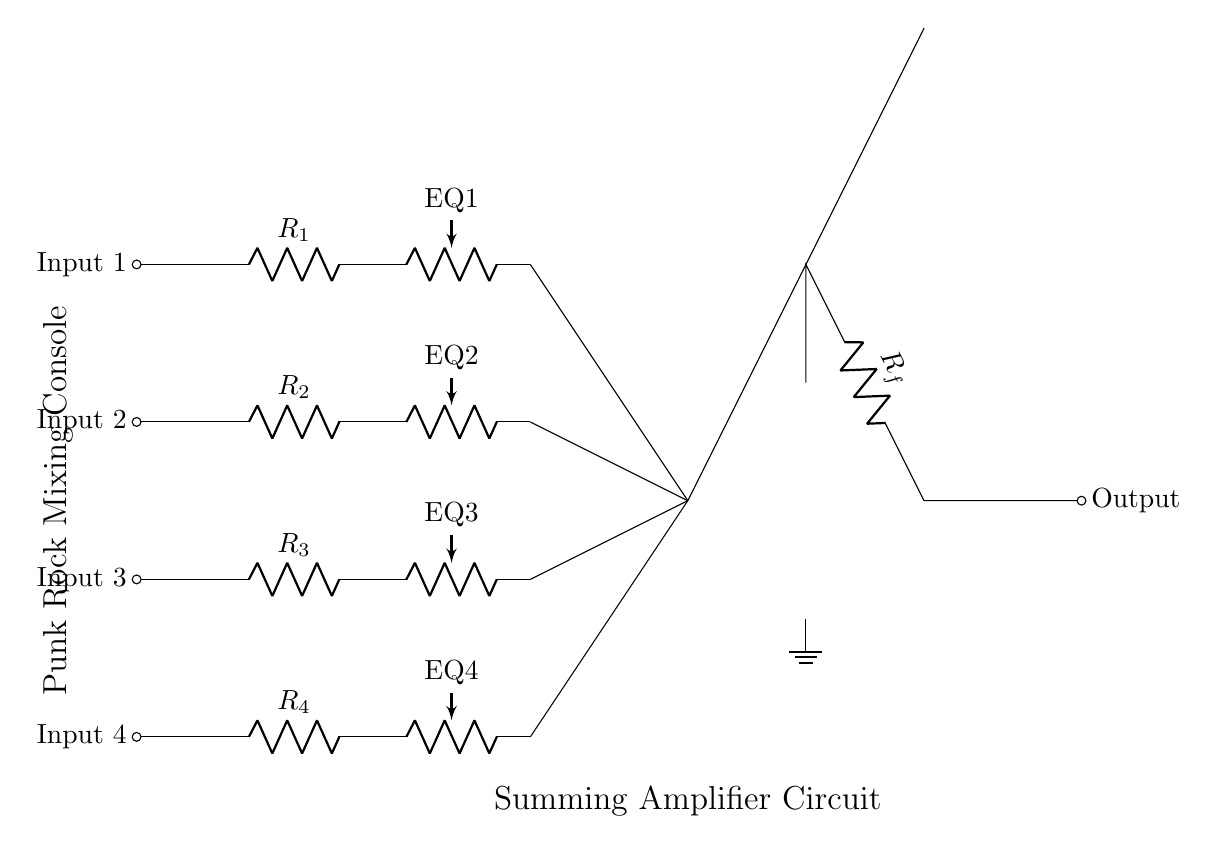What type of circuit is this? This circuit is a summing amplifier, which combines multiple input signals into a single output signal. The key feature is the presence of an operational amplifier configured to sum the inputs.
Answer: Summing amplifier How many input channels does the circuit have? The diagram shows four distinct input channels, each represented by a separate line leading to input resistors.
Answer: Four What component is used for equalization in this circuit? The circuit features four potentiometers labeled EQ1, EQ2, EQ3, and EQ4, which allow adjustment of the frequency response for each input channel.
Answer: Potentiometers What is the function of the resistor labeled R_f in this circuit? The resistor labeled R_f is the feedback resistor, which helps to set the gain and stability of the summing amplifier. It plays a crucial role in determining how much of the output is fed back into the input.
Answer: Feedback resistor Describe the connections leading to the summing point. Each input channel's signal flows through a respective input resistor to the summing point, where the signals are combined before reaching the operational amplifier for summation. This configuration allows for the blending of inputs.
Answer: Combined inputs What is the significance of grounding in this circuit? Grounding provides a reference point for the circuit, ensuring proper operation of the operational amplifier and stabilizing the signals by minimizing noise and interference.
Answer: Reference point 